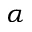Convert formula to latex. <formula><loc_0><loc_0><loc_500><loc_500>\alpha</formula> 